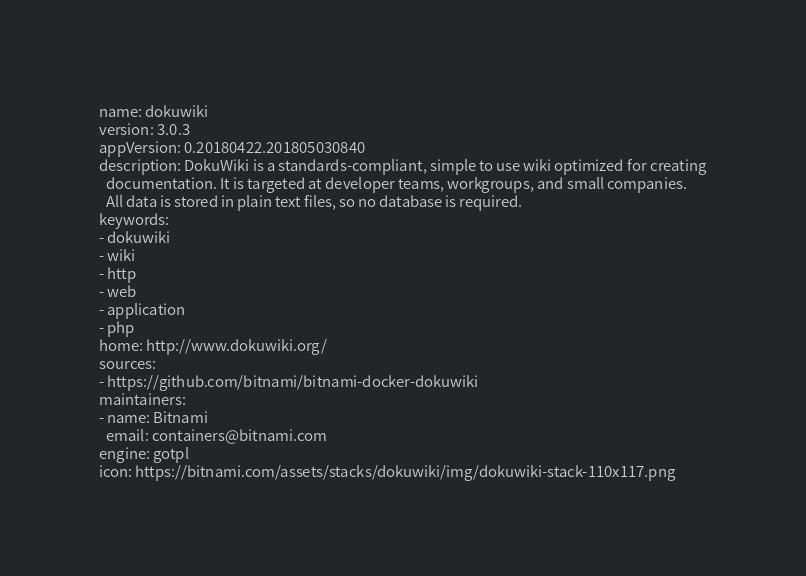<code> <loc_0><loc_0><loc_500><loc_500><_YAML_>name: dokuwiki
version: 3.0.3
appVersion: 0.20180422.201805030840
description: DokuWiki is a standards-compliant, simple to use wiki optimized for creating
  documentation. It is targeted at developer teams, workgroups, and small companies.
  All data is stored in plain text files, so no database is required.
keywords:
- dokuwiki
- wiki
- http
- web
- application
- php
home: http://www.dokuwiki.org/
sources:
- https://github.com/bitnami/bitnami-docker-dokuwiki
maintainers:
- name: Bitnami
  email: containers@bitnami.com
engine: gotpl
icon: https://bitnami.com/assets/stacks/dokuwiki/img/dokuwiki-stack-110x117.png
</code> 